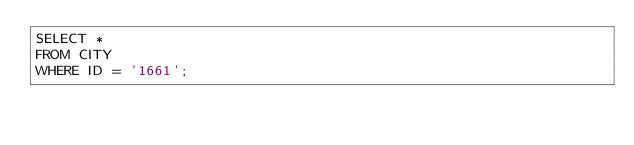Convert code to text. <code><loc_0><loc_0><loc_500><loc_500><_SQL_>SELECT *
FROM CITY
WHERE ID = '1661';</code> 